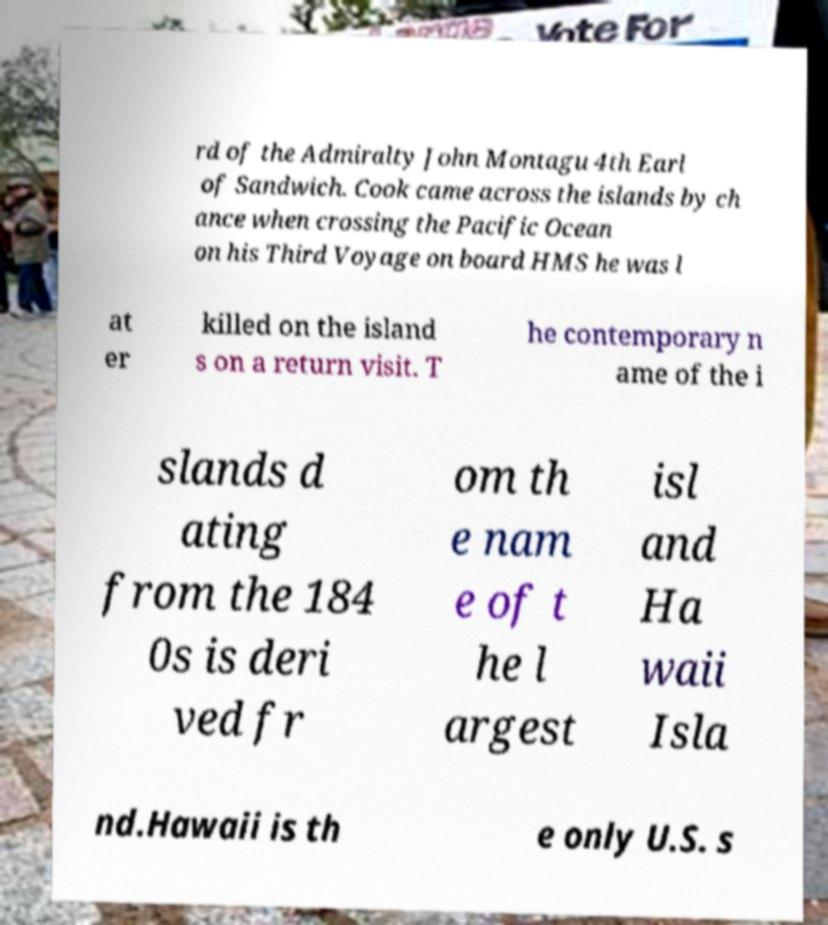I need the written content from this picture converted into text. Can you do that? rd of the Admiralty John Montagu 4th Earl of Sandwich. Cook came across the islands by ch ance when crossing the Pacific Ocean on his Third Voyage on board HMS he was l at er killed on the island s on a return visit. T he contemporary n ame of the i slands d ating from the 184 0s is deri ved fr om th e nam e of t he l argest isl and Ha waii Isla nd.Hawaii is th e only U.S. s 